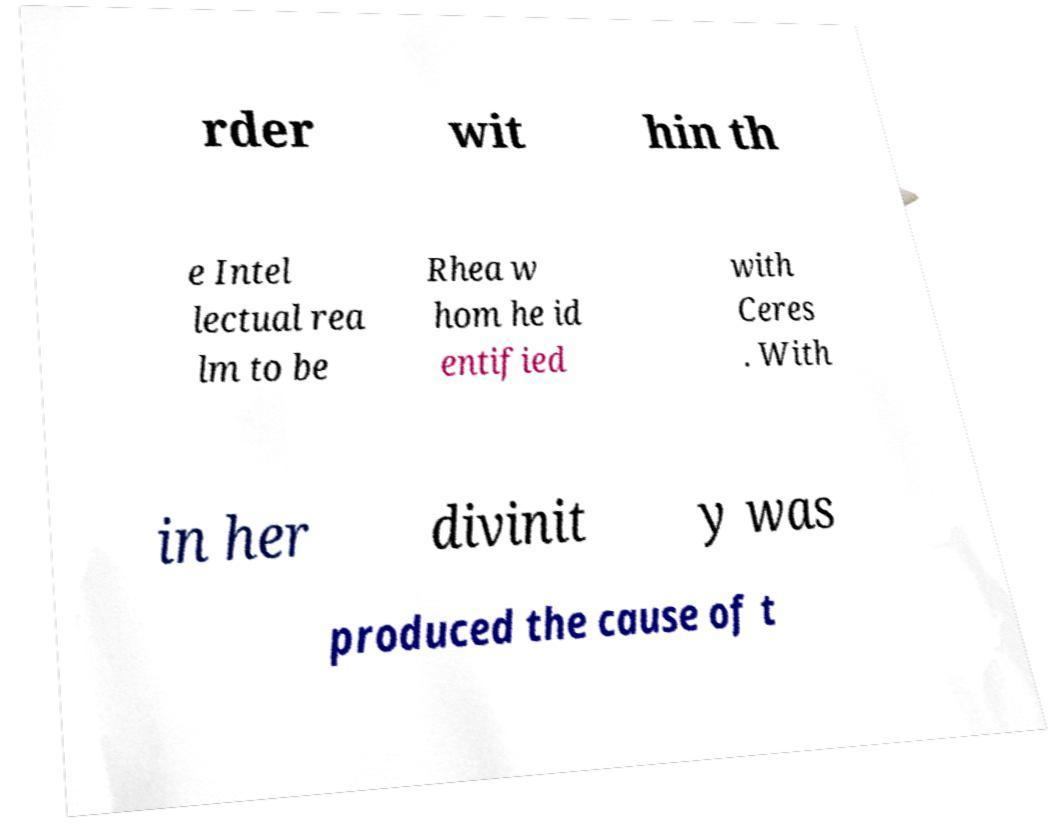For documentation purposes, I need the text within this image transcribed. Could you provide that? rder wit hin th e Intel lectual rea lm to be Rhea w hom he id entified with Ceres . With in her divinit y was produced the cause of t 